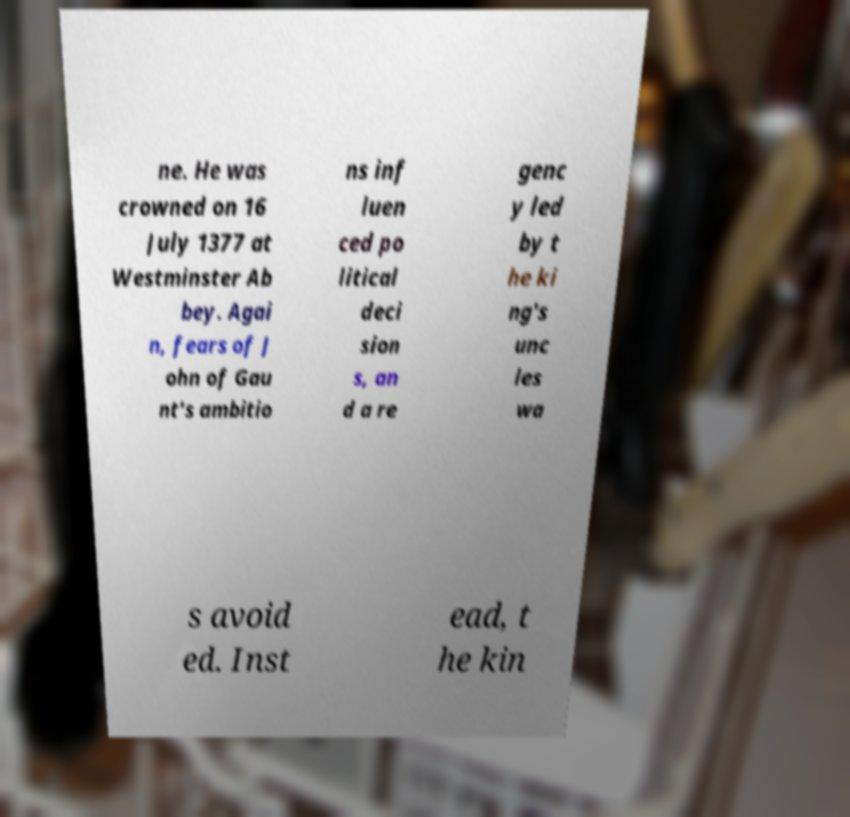Could you assist in decoding the text presented in this image and type it out clearly? ne. He was crowned on 16 July 1377 at Westminster Ab bey. Agai n, fears of J ohn of Gau nt's ambitio ns inf luen ced po litical deci sion s, an d a re genc y led by t he ki ng's unc les wa s avoid ed. Inst ead, t he kin 